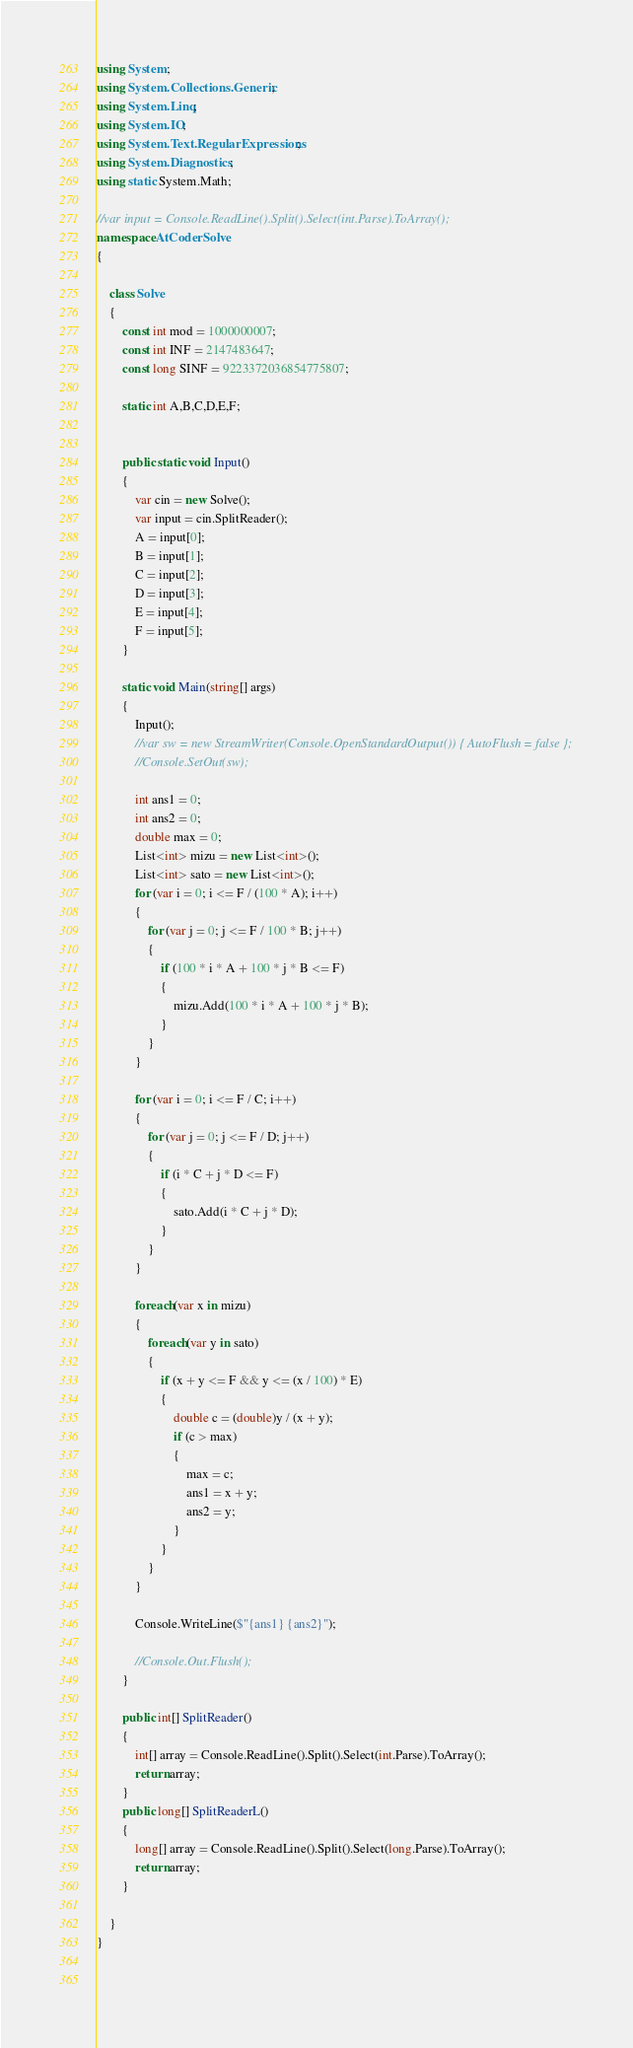Convert code to text. <code><loc_0><loc_0><loc_500><loc_500><_C#_>using System;
using System.Collections.Generic;
using System.Linq;
using System.IO;
using System.Text.RegularExpressions;
using System.Diagnostics;
using static System.Math;

//var input = Console.ReadLine().Split().Select(int.Parse).ToArray();
namespace AtCoderSolve
{

    class Solve
    {
        const int mod = 1000000007;
        const int INF = 2147483647;
        const long SINF = 9223372036854775807;

        static int A,B,C,D,E,F;
       

        public static void Input()
        {
            var cin = new Solve();
            var input = cin.SplitReader();
            A = input[0];
            B = input[1];
            C = input[2];
            D = input[3];
            E = input[4];
            F = input[5];
        }

        static void Main(string[] args)
        {
            Input();
            //var sw = new StreamWriter(Console.OpenStandardOutput()) { AutoFlush = false };
            //Console.SetOut(sw);

            int ans1 = 0;
            int ans2 = 0;
            double max = 0;
            List<int> mizu = new List<int>();
            List<int> sato = new List<int>();
            for (var i = 0; i <= F / (100 * A); i++) 
            {
                for (var j = 0; j <= F / 100 * B; j++) 
                {
                    if (100 * i * A + 100 * j * B <= F) 
                    {
                        mizu.Add(100 * i * A + 100 * j * B);
                    }
                }
            }

            for (var i = 0; i <= F / C; i++) 
            {
                for (var j = 0; j <= F / D; j++) 
                {
                    if (i * C + j * D <= F)
                    {
                        sato.Add(i * C + j * D);
                    }
                }
            }

            foreach(var x in mizu)
            {
                foreach(var y in sato)
                {
                    if (x + y <= F && y <= (x / 100) * E)
                    {
                        double c = (double)y / (x + y);
                        if (c > max)
                        {
                            max = c;
                            ans1 = x + y;
                            ans2 = y;
                        }
                    }
                }
            }

            Console.WriteLine($"{ans1} {ans2}");

            //Console.Out.Flush();
        }

        public int[] SplitReader()
        {
            int[] array = Console.ReadLine().Split().Select(int.Parse).ToArray();
            return array;
        }
        public long[] SplitReaderL()
        {
            long[] array = Console.ReadLine().Split().Select(long.Parse).ToArray();
            return array;
        }

    }
}

    

</code> 